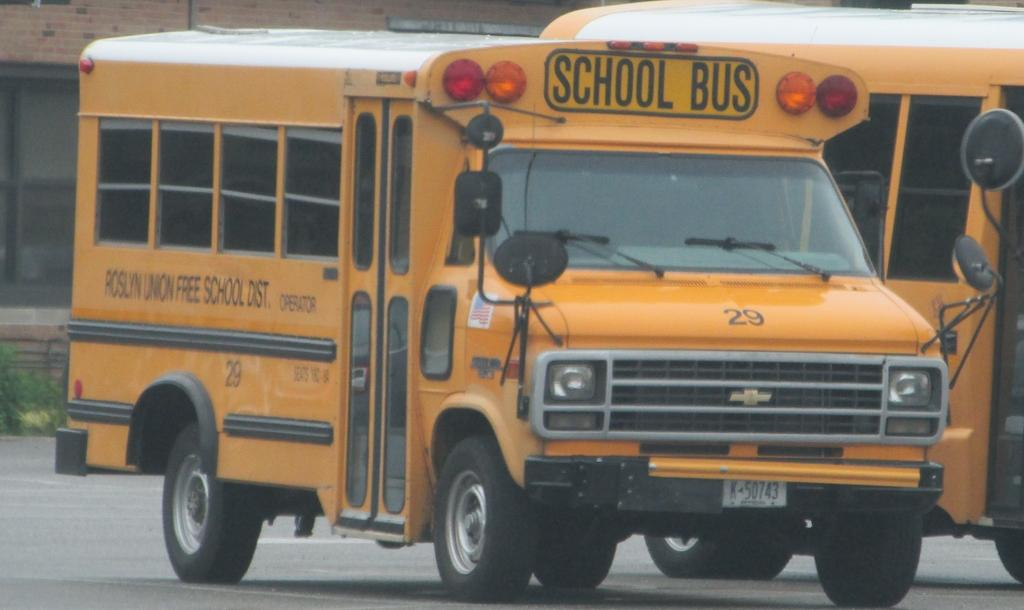<image>
Write a terse but informative summary of the picture. A Roslyn Union Free School District school bus. 